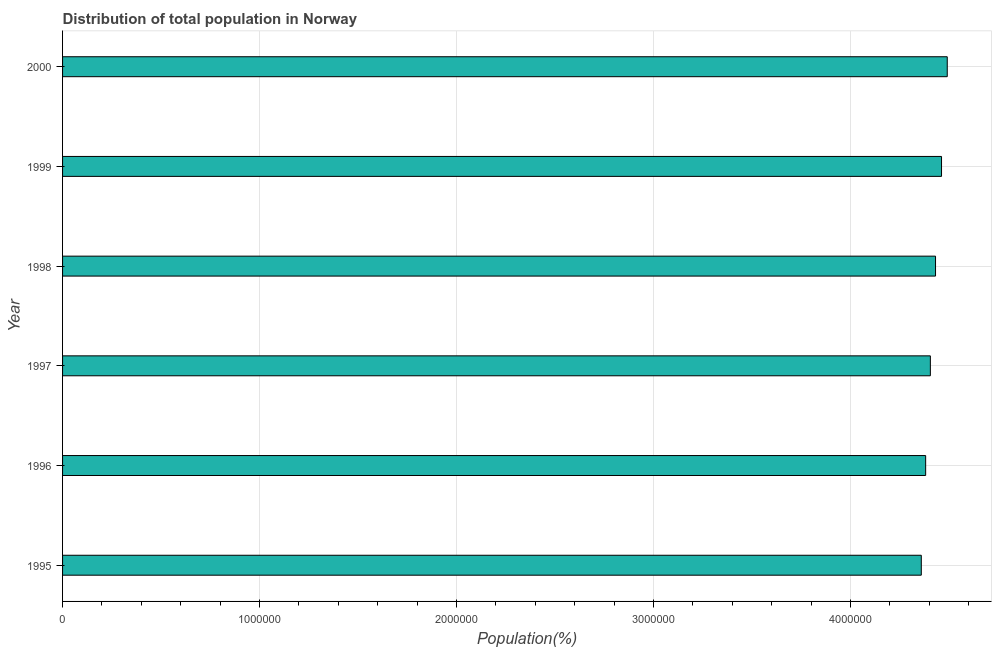What is the title of the graph?
Give a very brief answer. Distribution of total population in Norway . What is the label or title of the X-axis?
Your answer should be compact. Population(%). What is the label or title of the Y-axis?
Provide a succinct answer. Year. What is the population in 1995?
Provide a short and direct response. 4.36e+06. Across all years, what is the maximum population?
Offer a terse response. 4.49e+06. Across all years, what is the minimum population?
Offer a very short reply. 4.36e+06. What is the sum of the population?
Give a very brief answer. 2.65e+07. What is the difference between the population in 1998 and 2000?
Make the answer very short. -5.95e+04. What is the average population per year?
Ensure brevity in your answer.  4.42e+06. What is the median population?
Provide a succinct answer. 4.42e+06. Do a majority of the years between 1999 and 1995 (inclusive) have population greater than 2400000 %?
Your answer should be very brief. Yes. Is the difference between the population in 1995 and 1999 greater than the difference between any two years?
Your answer should be compact. No. What is the difference between the highest and the second highest population?
Ensure brevity in your answer.  2.91e+04. What is the difference between the highest and the lowest population?
Ensure brevity in your answer.  1.32e+05. How many bars are there?
Offer a very short reply. 6. Are all the bars in the graph horizontal?
Provide a short and direct response. Yes. What is the Population(%) of 1995?
Make the answer very short. 4.36e+06. What is the Population(%) of 1996?
Give a very brief answer. 4.38e+06. What is the Population(%) in 1997?
Offer a very short reply. 4.41e+06. What is the Population(%) in 1998?
Your answer should be very brief. 4.43e+06. What is the Population(%) in 1999?
Make the answer very short. 4.46e+06. What is the Population(%) in 2000?
Provide a short and direct response. 4.49e+06. What is the difference between the Population(%) in 1995 and 1996?
Your answer should be very brief. -2.22e+04. What is the difference between the Population(%) in 1995 and 1997?
Ensure brevity in your answer.  -4.60e+04. What is the difference between the Population(%) in 1995 and 1998?
Your answer should be compact. -7.23e+04. What is the difference between the Population(%) in 1995 and 1999?
Provide a short and direct response. -1.03e+05. What is the difference between the Population(%) in 1995 and 2000?
Make the answer very short. -1.32e+05. What is the difference between the Population(%) in 1996 and 1997?
Provide a succinct answer. -2.38e+04. What is the difference between the Population(%) in 1996 and 1998?
Your answer should be very brief. -5.01e+04. What is the difference between the Population(%) in 1996 and 1999?
Offer a very short reply. -8.06e+04. What is the difference between the Population(%) in 1996 and 2000?
Keep it short and to the point. -1.10e+05. What is the difference between the Population(%) in 1997 and 1998?
Provide a succinct answer. -2.63e+04. What is the difference between the Population(%) in 1997 and 1999?
Offer a very short reply. -5.68e+04. What is the difference between the Population(%) in 1997 and 2000?
Make the answer very short. -8.58e+04. What is the difference between the Population(%) in 1998 and 1999?
Offer a terse response. -3.04e+04. What is the difference between the Population(%) in 1998 and 2000?
Your response must be concise. -5.95e+04. What is the difference between the Population(%) in 1999 and 2000?
Offer a very short reply. -2.91e+04. What is the ratio of the Population(%) in 1995 to that in 1996?
Your answer should be very brief. 0.99. What is the ratio of the Population(%) in 1995 to that in 1997?
Your answer should be very brief. 0.99. What is the ratio of the Population(%) in 1995 to that in 1999?
Offer a terse response. 0.98. What is the ratio of the Population(%) in 1995 to that in 2000?
Your answer should be compact. 0.97. What is the ratio of the Population(%) in 1996 to that in 1997?
Your answer should be very brief. 0.99. What is the ratio of the Population(%) in 1996 to that in 1998?
Keep it short and to the point. 0.99. What is the ratio of the Population(%) in 1997 to that in 1999?
Your response must be concise. 0.99. What is the ratio of the Population(%) in 1997 to that in 2000?
Provide a succinct answer. 0.98. What is the ratio of the Population(%) in 1998 to that in 1999?
Your response must be concise. 0.99. What is the ratio of the Population(%) in 1999 to that in 2000?
Provide a short and direct response. 0.99. 